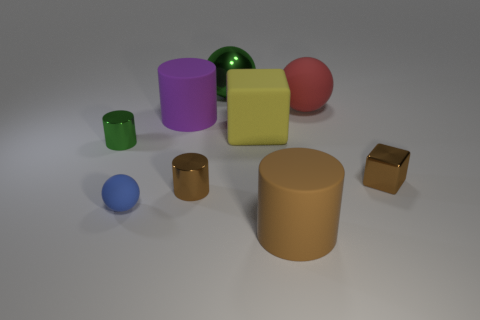Are there any rubber things that are in front of the small brown metal thing that is to the right of the shiny cylinder that is right of the blue rubber object?
Your answer should be compact. Yes. There is a large red object that is the same shape as the small blue rubber object; what material is it?
Ensure brevity in your answer.  Rubber. How many balls are big blue matte things or big green shiny objects?
Your answer should be compact. 1. Do the cylinder left of the small blue sphere and the cylinder that is in front of the small blue sphere have the same size?
Your response must be concise. No. What is the ball that is in front of the large cylinder behind the small brown metallic cylinder made of?
Offer a very short reply. Rubber. Are there fewer large cylinders that are in front of the brown matte cylinder than tiny red rubber cubes?
Your answer should be compact. No. There is a large red object that is made of the same material as the blue thing; what is its shape?
Offer a terse response. Sphere. What number of other things are there of the same shape as the red rubber object?
Offer a terse response. 2. What number of yellow things are either tiny cubes or matte cubes?
Offer a terse response. 1. Does the brown rubber object have the same shape as the small green metallic thing?
Your answer should be very brief. Yes. 